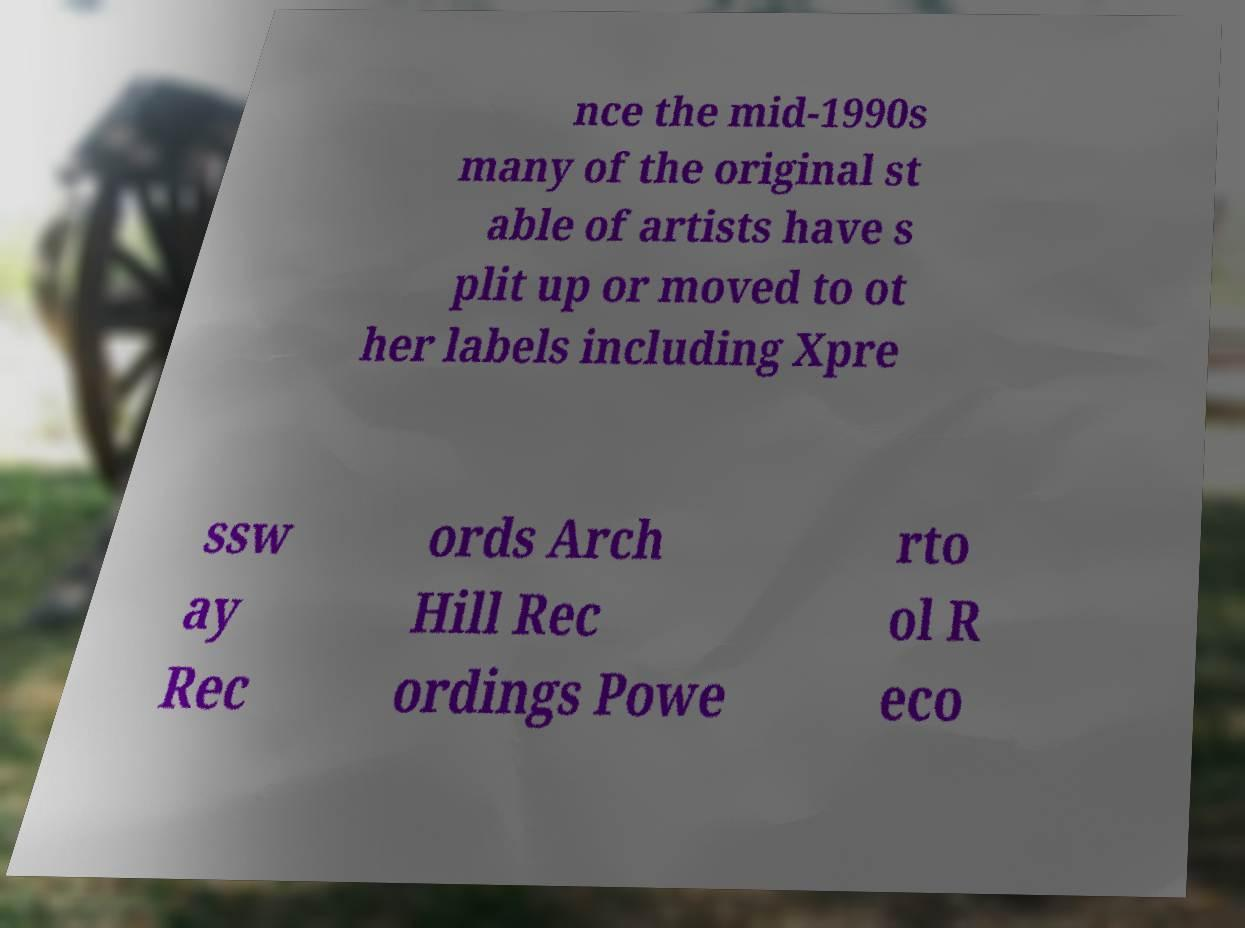Could you assist in decoding the text presented in this image and type it out clearly? nce the mid-1990s many of the original st able of artists have s plit up or moved to ot her labels including Xpre ssw ay Rec ords Arch Hill Rec ordings Powe rto ol R eco 